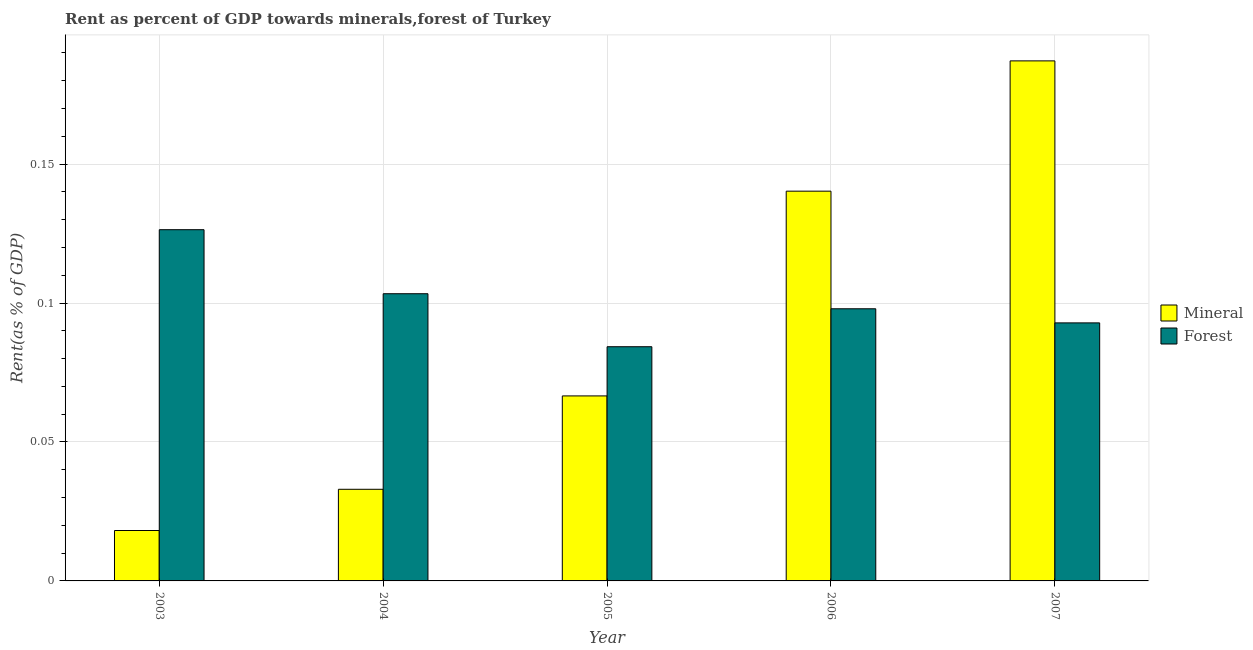How many different coloured bars are there?
Provide a succinct answer. 2. How many groups of bars are there?
Give a very brief answer. 5. Are the number of bars per tick equal to the number of legend labels?
Provide a succinct answer. Yes. How many bars are there on the 5th tick from the left?
Provide a succinct answer. 2. What is the label of the 5th group of bars from the left?
Offer a terse response. 2007. In how many cases, is the number of bars for a given year not equal to the number of legend labels?
Your answer should be very brief. 0. What is the forest rent in 2003?
Ensure brevity in your answer.  0.13. Across all years, what is the maximum forest rent?
Provide a short and direct response. 0.13. Across all years, what is the minimum mineral rent?
Make the answer very short. 0.02. In which year was the forest rent maximum?
Keep it short and to the point. 2003. In which year was the mineral rent minimum?
Keep it short and to the point. 2003. What is the total mineral rent in the graph?
Offer a very short reply. 0.45. What is the difference between the mineral rent in 2005 and that in 2007?
Make the answer very short. -0.12. What is the difference between the mineral rent in 2007 and the forest rent in 2003?
Keep it short and to the point. 0.17. What is the average mineral rent per year?
Your response must be concise. 0.09. In the year 2004, what is the difference between the mineral rent and forest rent?
Provide a short and direct response. 0. In how many years, is the mineral rent greater than 0.060000000000000005 %?
Make the answer very short. 3. What is the ratio of the mineral rent in 2004 to that in 2006?
Offer a terse response. 0.24. Is the difference between the mineral rent in 2005 and 2006 greater than the difference between the forest rent in 2005 and 2006?
Provide a succinct answer. No. What is the difference between the highest and the second highest mineral rent?
Ensure brevity in your answer.  0.05. What is the difference between the highest and the lowest mineral rent?
Make the answer very short. 0.17. In how many years, is the mineral rent greater than the average mineral rent taken over all years?
Your answer should be compact. 2. What does the 1st bar from the left in 2007 represents?
Your answer should be very brief. Mineral. What does the 2nd bar from the right in 2004 represents?
Provide a short and direct response. Mineral. Are all the bars in the graph horizontal?
Your answer should be compact. No. Are the values on the major ticks of Y-axis written in scientific E-notation?
Your answer should be compact. No. Does the graph contain grids?
Make the answer very short. Yes. Where does the legend appear in the graph?
Provide a succinct answer. Center right. How are the legend labels stacked?
Offer a terse response. Vertical. What is the title of the graph?
Keep it short and to the point. Rent as percent of GDP towards minerals,forest of Turkey. Does "Long-term debt" appear as one of the legend labels in the graph?
Your answer should be very brief. No. What is the label or title of the Y-axis?
Provide a succinct answer. Rent(as % of GDP). What is the Rent(as % of GDP) in Mineral in 2003?
Your response must be concise. 0.02. What is the Rent(as % of GDP) in Forest in 2003?
Your answer should be very brief. 0.13. What is the Rent(as % of GDP) in Mineral in 2004?
Provide a short and direct response. 0.03. What is the Rent(as % of GDP) of Forest in 2004?
Your response must be concise. 0.1. What is the Rent(as % of GDP) in Mineral in 2005?
Your answer should be very brief. 0.07. What is the Rent(as % of GDP) in Forest in 2005?
Your answer should be very brief. 0.08. What is the Rent(as % of GDP) in Mineral in 2006?
Your response must be concise. 0.14. What is the Rent(as % of GDP) of Forest in 2006?
Provide a short and direct response. 0.1. What is the Rent(as % of GDP) in Mineral in 2007?
Your answer should be compact. 0.19. What is the Rent(as % of GDP) of Forest in 2007?
Keep it short and to the point. 0.09. Across all years, what is the maximum Rent(as % of GDP) in Mineral?
Offer a terse response. 0.19. Across all years, what is the maximum Rent(as % of GDP) in Forest?
Your answer should be very brief. 0.13. Across all years, what is the minimum Rent(as % of GDP) in Mineral?
Make the answer very short. 0.02. Across all years, what is the minimum Rent(as % of GDP) of Forest?
Provide a succinct answer. 0.08. What is the total Rent(as % of GDP) of Mineral in the graph?
Your answer should be very brief. 0.45. What is the total Rent(as % of GDP) of Forest in the graph?
Offer a terse response. 0.5. What is the difference between the Rent(as % of GDP) in Mineral in 2003 and that in 2004?
Give a very brief answer. -0.01. What is the difference between the Rent(as % of GDP) in Forest in 2003 and that in 2004?
Your answer should be very brief. 0.02. What is the difference between the Rent(as % of GDP) in Mineral in 2003 and that in 2005?
Provide a succinct answer. -0.05. What is the difference between the Rent(as % of GDP) in Forest in 2003 and that in 2005?
Provide a short and direct response. 0.04. What is the difference between the Rent(as % of GDP) in Mineral in 2003 and that in 2006?
Keep it short and to the point. -0.12. What is the difference between the Rent(as % of GDP) of Forest in 2003 and that in 2006?
Ensure brevity in your answer.  0.03. What is the difference between the Rent(as % of GDP) in Mineral in 2003 and that in 2007?
Your answer should be very brief. -0.17. What is the difference between the Rent(as % of GDP) in Forest in 2003 and that in 2007?
Make the answer very short. 0.03. What is the difference between the Rent(as % of GDP) of Mineral in 2004 and that in 2005?
Keep it short and to the point. -0.03. What is the difference between the Rent(as % of GDP) of Forest in 2004 and that in 2005?
Keep it short and to the point. 0.02. What is the difference between the Rent(as % of GDP) of Mineral in 2004 and that in 2006?
Make the answer very short. -0.11. What is the difference between the Rent(as % of GDP) of Forest in 2004 and that in 2006?
Provide a succinct answer. 0.01. What is the difference between the Rent(as % of GDP) of Mineral in 2004 and that in 2007?
Offer a terse response. -0.15. What is the difference between the Rent(as % of GDP) in Forest in 2004 and that in 2007?
Make the answer very short. 0.01. What is the difference between the Rent(as % of GDP) in Mineral in 2005 and that in 2006?
Your answer should be very brief. -0.07. What is the difference between the Rent(as % of GDP) in Forest in 2005 and that in 2006?
Offer a very short reply. -0.01. What is the difference between the Rent(as % of GDP) of Mineral in 2005 and that in 2007?
Your response must be concise. -0.12. What is the difference between the Rent(as % of GDP) of Forest in 2005 and that in 2007?
Provide a succinct answer. -0.01. What is the difference between the Rent(as % of GDP) of Mineral in 2006 and that in 2007?
Your response must be concise. -0.05. What is the difference between the Rent(as % of GDP) in Forest in 2006 and that in 2007?
Your answer should be very brief. 0.01. What is the difference between the Rent(as % of GDP) of Mineral in 2003 and the Rent(as % of GDP) of Forest in 2004?
Provide a succinct answer. -0.09. What is the difference between the Rent(as % of GDP) of Mineral in 2003 and the Rent(as % of GDP) of Forest in 2005?
Ensure brevity in your answer.  -0.07. What is the difference between the Rent(as % of GDP) in Mineral in 2003 and the Rent(as % of GDP) in Forest in 2006?
Your response must be concise. -0.08. What is the difference between the Rent(as % of GDP) in Mineral in 2003 and the Rent(as % of GDP) in Forest in 2007?
Ensure brevity in your answer.  -0.07. What is the difference between the Rent(as % of GDP) of Mineral in 2004 and the Rent(as % of GDP) of Forest in 2005?
Your answer should be very brief. -0.05. What is the difference between the Rent(as % of GDP) in Mineral in 2004 and the Rent(as % of GDP) in Forest in 2006?
Give a very brief answer. -0.07. What is the difference between the Rent(as % of GDP) in Mineral in 2004 and the Rent(as % of GDP) in Forest in 2007?
Make the answer very short. -0.06. What is the difference between the Rent(as % of GDP) in Mineral in 2005 and the Rent(as % of GDP) in Forest in 2006?
Offer a terse response. -0.03. What is the difference between the Rent(as % of GDP) in Mineral in 2005 and the Rent(as % of GDP) in Forest in 2007?
Offer a very short reply. -0.03. What is the difference between the Rent(as % of GDP) of Mineral in 2006 and the Rent(as % of GDP) of Forest in 2007?
Provide a succinct answer. 0.05. What is the average Rent(as % of GDP) in Mineral per year?
Offer a terse response. 0.09. What is the average Rent(as % of GDP) in Forest per year?
Your response must be concise. 0.1. In the year 2003, what is the difference between the Rent(as % of GDP) of Mineral and Rent(as % of GDP) of Forest?
Keep it short and to the point. -0.11. In the year 2004, what is the difference between the Rent(as % of GDP) of Mineral and Rent(as % of GDP) of Forest?
Your answer should be compact. -0.07. In the year 2005, what is the difference between the Rent(as % of GDP) of Mineral and Rent(as % of GDP) of Forest?
Provide a short and direct response. -0.02. In the year 2006, what is the difference between the Rent(as % of GDP) in Mineral and Rent(as % of GDP) in Forest?
Your answer should be compact. 0.04. In the year 2007, what is the difference between the Rent(as % of GDP) of Mineral and Rent(as % of GDP) of Forest?
Ensure brevity in your answer.  0.09. What is the ratio of the Rent(as % of GDP) in Mineral in 2003 to that in 2004?
Your response must be concise. 0.55. What is the ratio of the Rent(as % of GDP) in Forest in 2003 to that in 2004?
Keep it short and to the point. 1.22. What is the ratio of the Rent(as % of GDP) of Mineral in 2003 to that in 2005?
Provide a succinct answer. 0.27. What is the ratio of the Rent(as % of GDP) of Forest in 2003 to that in 2005?
Your answer should be compact. 1.5. What is the ratio of the Rent(as % of GDP) in Mineral in 2003 to that in 2006?
Ensure brevity in your answer.  0.13. What is the ratio of the Rent(as % of GDP) in Forest in 2003 to that in 2006?
Your answer should be very brief. 1.29. What is the ratio of the Rent(as % of GDP) of Mineral in 2003 to that in 2007?
Your answer should be compact. 0.1. What is the ratio of the Rent(as % of GDP) of Forest in 2003 to that in 2007?
Your response must be concise. 1.36. What is the ratio of the Rent(as % of GDP) of Mineral in 2004 to that in 2005?
Make the answer very short. 0.5. What is the ratio of the Rent(as % of GDP) of Forest in 2004 to that in 2005?
Keep it short and to the point. 1.23. What is the ratio of the Rent(as % of GDP) of Mineral in 2004 to that in 2006?
Give a very brief answer. 0.24. What is the ratio of the Rent(as % of GDP) in Forest in 2004 to that in 2006?
Offer a very short reply. 1.06. What is the ratio of the Rent(as % of GDP) of Mineral in 2004 to that in 2007?
Provide a succinct answer. 0.18. What is the ratio of the Rent(as % of GDP) of Forest in 2004 to that in 2007?
Give a very brief answer. 1.11. What is the ratio of the Rent(as % of GDP) of Mineral in 2005 to that in 2006?
Your answer should be very brief. 0.47. What is the ratio of the Rent(as % of GDP) of Forest in 2005 to that in 2006?
Make the answer very short. 0.86. What is the ratio of the Rent(as % of GDP) in Mineral in 2005 to that in 2007?
Your answer should be compact. 0.36. What is the ratio of the Rent(as % of GDP) of Forest in 2005 to that in 2007?
Provide a short and direct response. 0.91. What is the ratio of the Rent(as % of GDP) of Mineral in 2006 to that in 2007?
Give a very brief answer. 0.75. What is the ratio of the Rent(as % of GDP) in Forest in 2006 to that in 2007?
Make the answer very short. 1.05. What is the difference between the highest and the second highest Rent(as % of GDP) in Mineral?
Provide a succinct answer. 0.05. What is the difference between the highest and the second highest Rent(as % of GDP) in Forest?
Your answer should be very brief. 0.02. What is the difference between the highest and the lowest Rent(as % of GDP) in Mineral?
Ensure brevity in your answer.  0.17. What is the difference between the highest and the lowest Rent(as % of GDP) of Forest?
Provide a short and direct response. 0.04. 